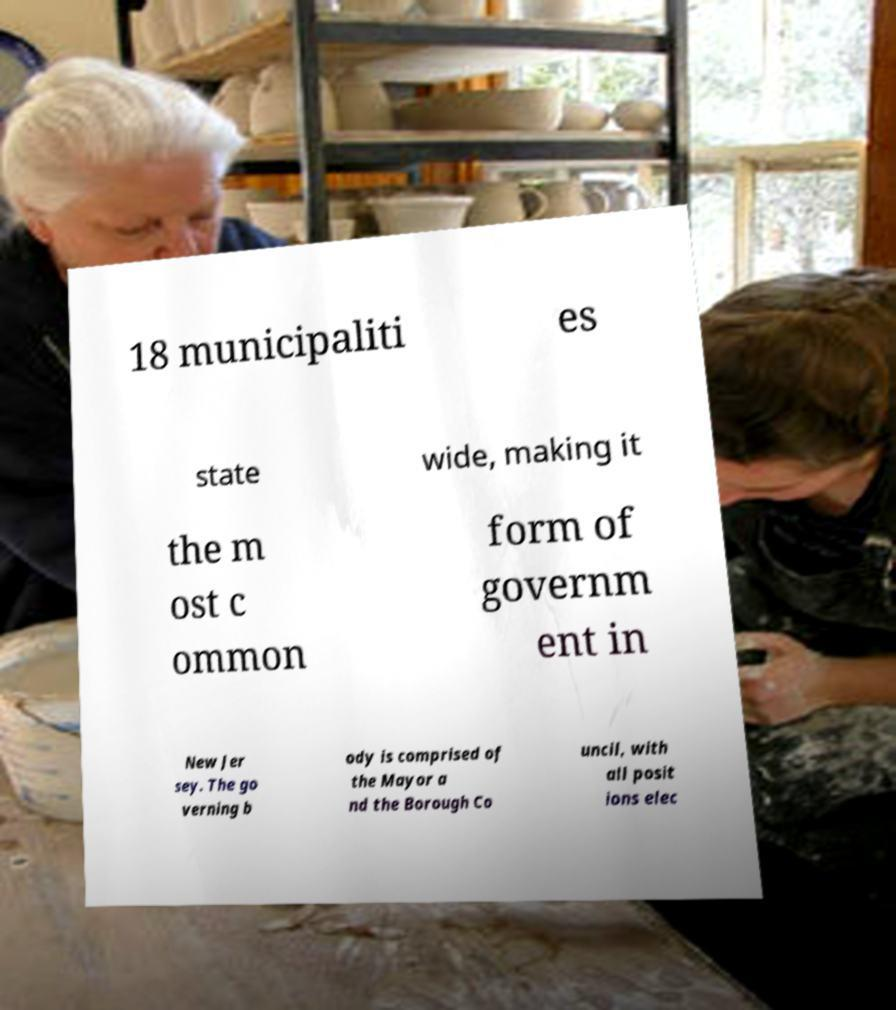There's text embedded in this image that I need extracted. Can you transcribe it verbatim? 18 municipaliti es state wide, making it the m ost c ommon form of governm ent in New Jer sey. The go verning b ody is comprised of the Mayor a nd the Borough Co uncil, with all posit ions elec 